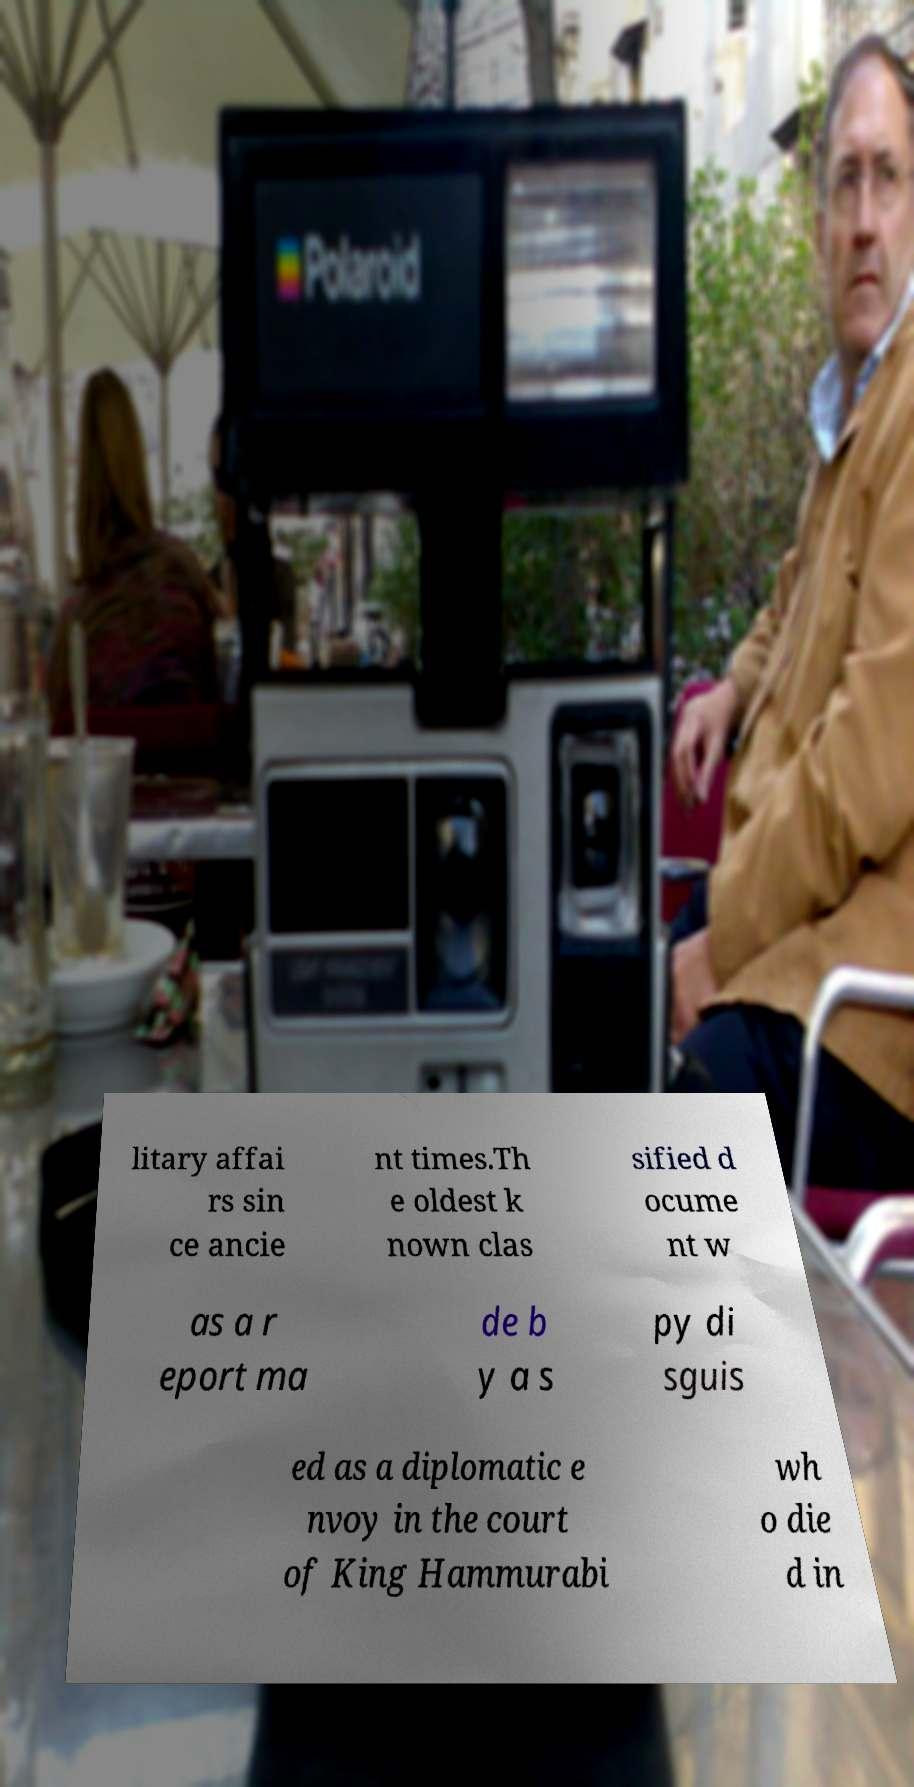Can you read and provide the text displayed in the image?This photo seems to have some interesting text. Can you extract and type it out for me? litary affai rs sin ce ancie nt times.Th e oldest k nown clas sified d ocume nt w as a r eport ma de b y a s py di sguis ed as a diplomatic e nvoy in the court of King Hammurabi wh o die d in 